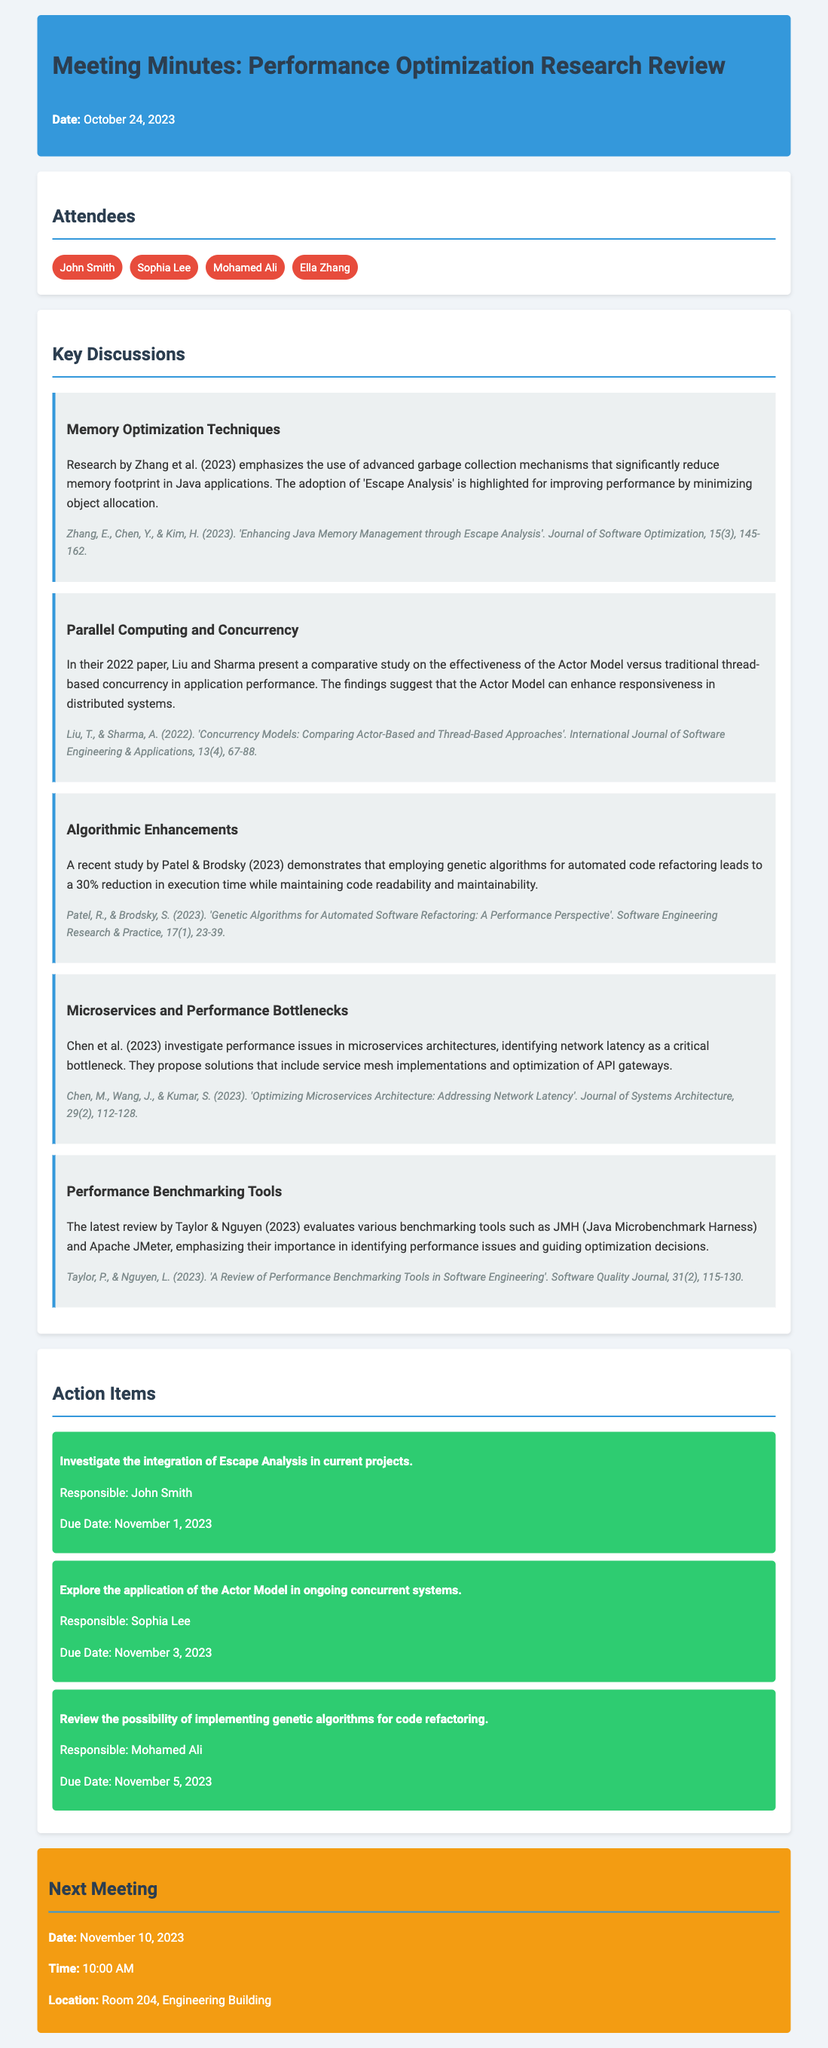what is the date of the meeting? The meeting date is mentioned at the beginning of the document.
Answer: October 24, 2023 who is responsible for investigating the integration of Escape Analysis in current projects? The document lists action items along with the responsible person's names.
Answer: John Smith which technique is emphasized for memory optimization in Java applications? The memory optimization section refers to specific mechanisms mentioned in the research.
Answer: Escape Analysis which concurrency model is compared with traditional thread-based concurrency? The discussion includes a comparative study on different concurrency models.
Answer: Actor Model what significant performance reduction is achieved through genetic algorithms according to Patel & Brodsky? The document provides specific percentage improvements related to genetic algorithms.
Answer: 30% what is the location of the next meeting? The next meeting section specifies the location of the upcoming meeting.
Answer: Room 204, Engineering Building which publication discusses performance issues in microservices architectures? The microservices section refers to specific research identifying performance bottlenecks.
Answer: Chen et al. (2023) when is the due date for exploring the application of the Actor Model? Each action item lists a due date.
Answer: November 3, 2023 how many attendees were present at the meeting? The attendees section lists each participant by name.
Answer: Four 